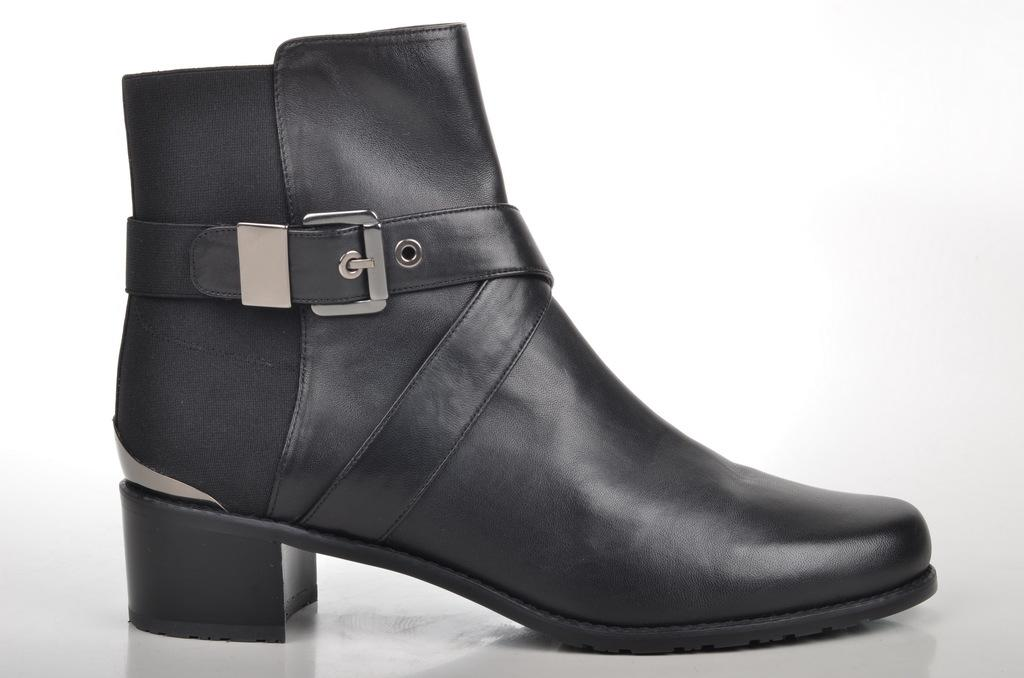What object is the main focus of the image? There is a boot in the image. Where is the boot located? The boot is on a platform. How many lizards can be seen crawling on the boot in the image? There are no lizards present in the image; it only features a boot on a platform. 